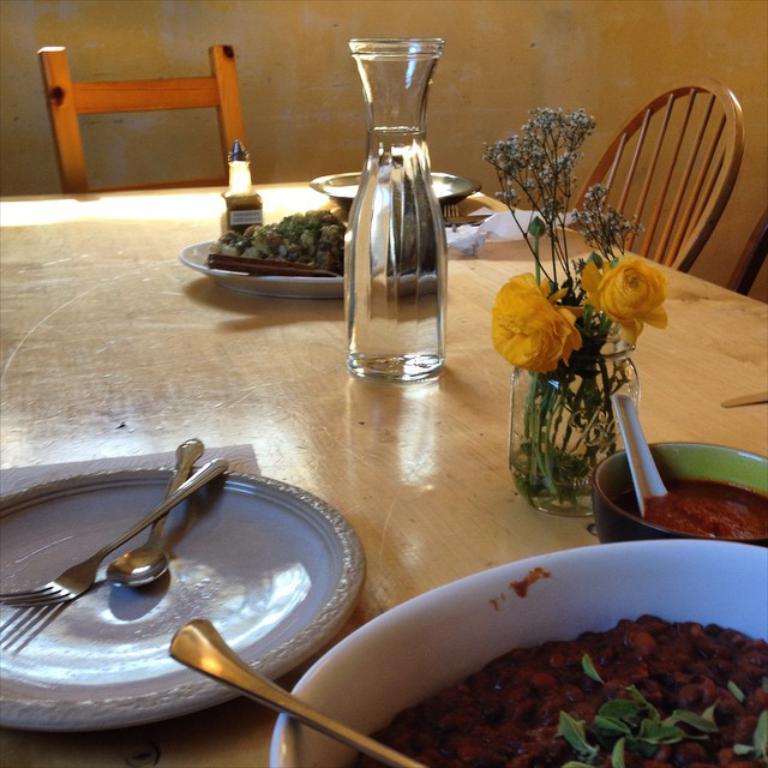Describe this image in one or two sentences. In this image we can see plates, forks, spoons, bowls with food items, flower vase, glass jar with water and a few more things are kept on the wooden table. In the background, we can see chairs and the wall. 